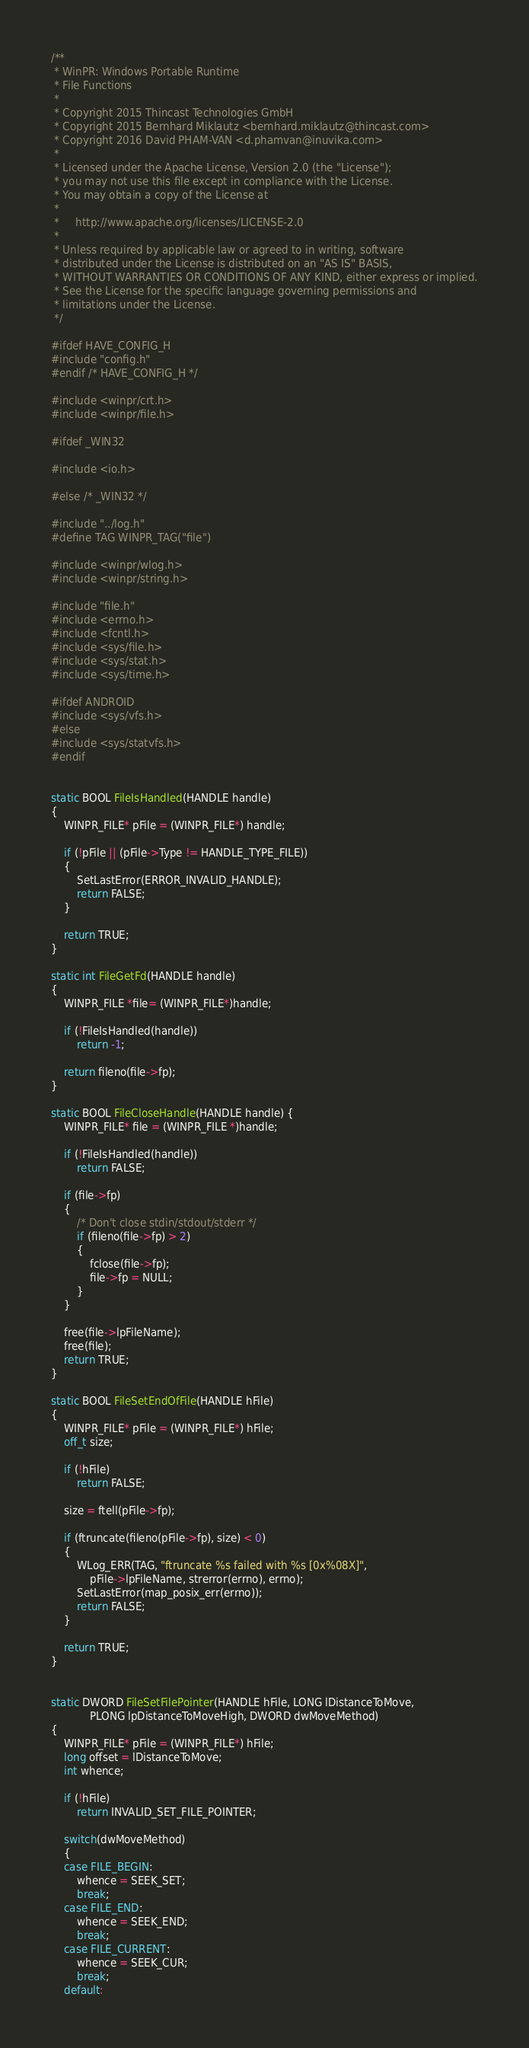Convert code to text. <code><loc_0><loc_0><loc_500><loc_500><_C_>/**
 * WinPR: Windows Portable Runtime
 * File Functions
 *
 * Copyright 2015 Thincast Technologies GmbH
 * Copyright 2015 Bernhard Miklautz <bernhard.miklautz@thincast.com>
 * Copyright 2016 David PHAM-VAN <d.phamvan@inuvika.com>
 *
 * Licensed under the Apache License, Version 2.0 (the "License");
 * you may not use this file except in compliance with the License.
 * You may obtain a copy of the License at
 *
 *     http://www.apache.org/licenses/LICENSE-2.0
 *
 * Unless required by applicable law or agreed to in writing, software
 * distributed under the License is distributed on an "AS IS" BASIS,
 * WITHOUT WARRANTIES OR CONDITIONS OF ANY KIND, either express or implied.
 * See the License for the specific language governing permissions and
 * limitations under the License.
 */

#ifdef HAVE_CONFIG_H
#include "config.h"
#endif /* HAVE_CONFIG_H */

#include <winpr/crt.h>
#include <winpr/file.h>

#ifdef _WIN32

#include <io.h>

#else /* _WIN32 */

#include "../log.h"
#define TAG WINPR_TAG("file")

#include <winpr/wlog.h>
#include <winpr/string.h>

#include "file.h"
#include <errno.h>
#include <fcntl.h>
#include <sys/file.h>
#include <sys/stat.h>
#include <sys/time.h>

#ifdef ANDROID
#include <sys/vfs.h>
#else
#include <sys/statvfs.h>
#endif


static BOOL FileIsHandled(HANDLE handle)
{
	WINPR_FILE* pFile = (WINPR_FILE*) handle;

	if (!pFile || (pFile->Type != HANDLE_TYPE_FILE))
	{
		SetLastError(ERROR_INVALID_HANDLE);
		return FALSE;
	}

	return TRUE;
}

static int FileGetFd(HANDLE handle)
{
	WINPR_FILE *file= (WINPR_FILE*)handle;

	if (!FileIsHandled(handle))
		return -1;

	return fileno(file->fp);
}

static BOOL FileCloseHandle(HANDLE handle) {
	WINPR_FILE* file = (WINPR_FILE *)handle;

	if (!FileIsHandled(handle))
		return FALSE;

	if (file->fp)
	{
		/* Don't close stdin/stdout/stderr */
		if (fileno(file->fp) > 2)
		{
			fclose(file->fp);
			file->fp = NULL;
		}
	}

	free(file->lpFileName);
	free(file);
	return TRUE;
}

static BOOL FileSetEndOfFile(HANDLE hFile)
{
	WINPR_FILE* pFile = (WINPR_FILE*) hFile;
	off_t size;

	if (!hFile)
		return FALSE;

	size = ftell(pFile->fp);

	if (ftruncate(fileno(pFile->fp), size) < 0)
	{
		WLog_ERR(TAG, "ftruncate %s failed with %s [0x%08X]",
			pFile->lpFileName, strerror(errno), errno);
		SetLastError(map_posix_err(errno));
		return FALSE;
	}

	return TRUE;
}


static DWORD FileSetFilePointer(HANDLE hFile, LONG lDistanceToMove,
			PLONG lpDistanceToMoveHigh, DWORD dwMoveMethod)
{
	WINPR_FILE* pFile = (WINPR_FILE*) hFile;
	long offset = lDistanceToMove;
	int whence;

	if (!hFile)
		return INVALID_SET_FILE_POINTER;

	switch(dwMoveMethod)
	{
	case FILE_BEGIN:
		whence = SEEK_SET;
		break;
	case FILE_END:
		whence = SEEK_END;
		break;
	case FILE_CURRENT:
		whence = SEEK_CUR;
		break;
	default:</code> 